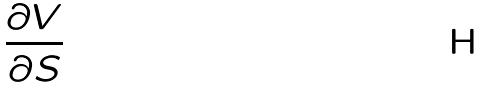Convert formula to latex. <formula><loc_0><loc_0><loc_500><loc_500>\frac { \partial V } { \partial S }</formula> 